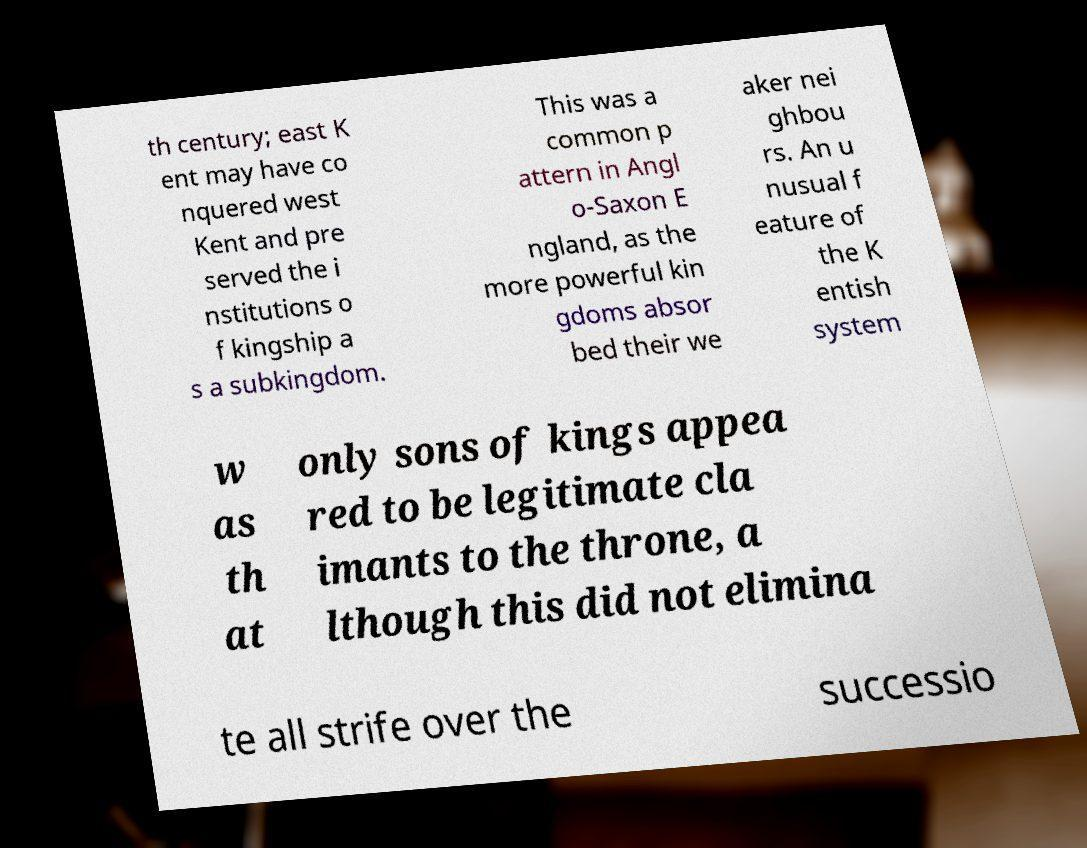For documentation purposes, I need the text within this image transcribed. Could you provide that? th century; east K ent may have co nquered west Kent and pre served the i nstitutions o f kingship a s a subkingdom. This was a common p attern in Angl o-Saxon E ngland, as the more powerful kin gdoms absor bed their we aker nei ghbou rs. An u nusual f eature of the K entish system w as th at only sons of kings appea red to be legitimate cla imants to the throne, a lthough this did not elimina te all strife over the successio 